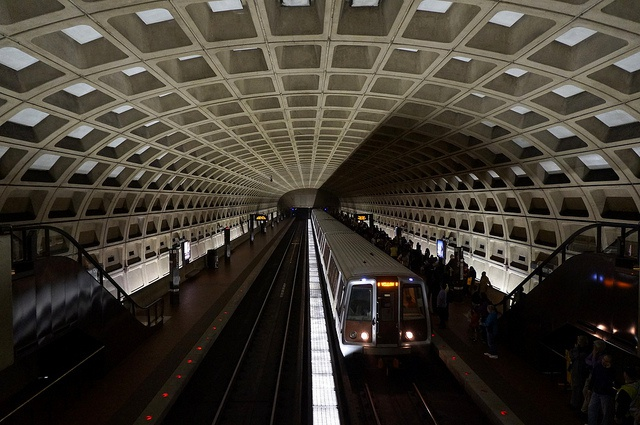Describe the objects in this image and their specific colors. I can see train in black and gray tones, people in black tones, people in black tones, people in black tones, and people in black tones in this image. 